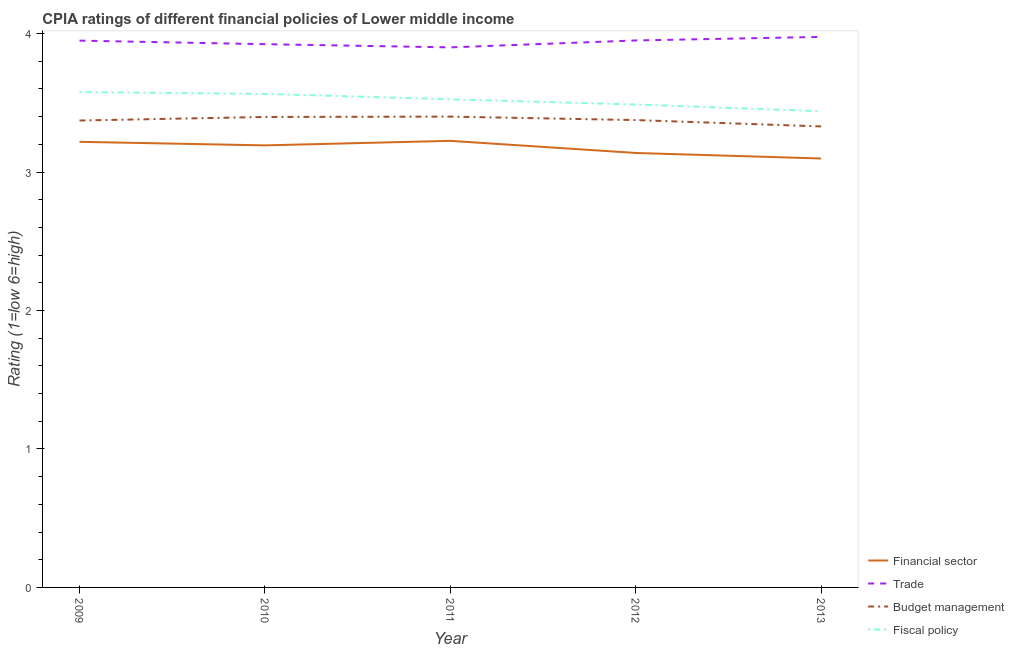How many different coloured lines are there?
Offer a very short reply. 4. What is the cpia rating of fiscal policy in 2013?
Your answer should be compact. 3.44. Across all years, what is the maximum cpia rating of trade?
Provide a short and direct response. 3.98. Across all years, what is the minimum cpia rating of financial sector?
Give a very brief answer. 3.1. In which year was the cpia rating of budget management maximum?
Provide a succinct answer. 2011. What is the total cpia rating of financial sector in the graph?
Make the answer very short. 15.87. What is the difference between the cpia rating of financial sector in 2011 and that in 2013?
Your answer should be compact. 0.13. What is the difference between the cpia rating of trade in 2011 and the cpia rating of fiscal policy in 2012?
Make the answer very short. 0.41. What is the average cpia rating of fiscal policy per year?
Your answer should be compact. 3.52. In the year 2012, what is the difference between the cpia rating of financial sector and cpia rating of budget management?
Provide a succinct answer. -0.24. In how many years, is the cpia rating of budget management greater than 2.8?
Your answer should be compact. 5. What is the ratio of the cpia rating of fiscal policy in 2012 to that in 2013?
Give a very brief answer. 1.01. What is the difference between the highest and the second highest cpia rating of trade?
Offer a very short reply. 0.03. What is the difference between the highest and the lowest cpia rating of financial sector?
Offer a very short reply. 0.13. In how many years, is the cpia rating of financial sector greater than the average cpia rating of financial sector taken over all years?
Offer a very short reply. 3. Is it the case that in every year, the sum of the cpia rating of financial sector and cpia rating of budget management is greater than the sum of cpia rating of fiscal policy and cpia rating of trade?
Provide a succinct answer. No. Is it the case that in every year, the sum of the cpia rating of financial sector and cpia rating of trade is greater than the cpia rating of budget management?
Keep it short and to the point. Yes. Is the cpia rating of trade strictly less than the cpia rating of financial sector over the years?
Give a very brief answer. No. How many lines are there?
Provide a succinct answer. 4. What is the difference between two consecutive major ticks on the Y-axis?
Provide a succinct answer. 1. Does the graph contain grids?
Your response must be concise. No. Where does the legend appear in the graph?
Your response must be concise. Bottom right. What is the title of the graph?
Offer a terse response. CPIA ratings of different financial policies of Lower middle income. What is the Rating (1=low 6=high) in Financial sector in 2009?
Keep it short and to the point. 3.22. What is the Rating (1=low 6=high) in Trade in 2009?
Make the answer very short. 3.95. What is the Rating (1=low 6=high) in Budget management in 2009?
Make the answer very short. 3.37. What is the Rating (1=low 6=high) of Fiscal policy in 2009?
Your response must be concise. 3.58. What is the Rating (1=low 6=high) of Financial sector in 2010?
Your answer should be very brief. 3.19. What is the Rating (1=low 6=high) of Trade in 2010?
Provide a succinct answer. 3.92. What is the Rating (1=low 6=high) in Budget management in 2010?
Provide a short and direct response. 3.4. What is the Rating (1=low 6=high) in Fiscal policy in 2010?
Provide a short and direct response. 3.56. What is the Rating (1=low 6=high) of Financial sector in 2011?
Offer a very short reply. 3.23. What is the Rating (1=low 6=high) of Fiscal policy in 2011?
Ensure brevity in your answer.  3.52. What is the Rating (1=low 6=high) of Financial sector in 2012?
Ensure brevity in your answer.  3.14. What is the Rating (1=low 6=high) of Trade in 2012?
Ensure brevity in your answer.  3.95. What is the Rating (1=low 6=high) of Budget management in 2012?
Offer a very short reply. 3.38. What is the Rating (1=low 6=high) in Fiscal policy in 2012?
Make the answer very short. 3.49. What is the Rating (1=low 6=high) in Financial sector in 2013?
Provide a short and direct response. 3.1. What is the Rating (1=low 6=high) of Trade in 2013?
Give a very brief answer. 3.98. What is the Rating (1=low 6=high) of Budget management in 2013?
Your answer should be compact. 3.33. What is the Rating (1=low 6=high) in Fiscal policy in 2013?
Your response must be concise. 3.44. Across all years, what is the maximum Rating (1=low 6=high) in Financial sector?
Keep it short and to the point. 3.23. Across all years, what is the maximum Rating (1=low 6=high) in Trade?
Ensure brevity in your answer.  3.98. Across all years, what is the maximum Rating (1=low 6=high) of Fiscal policy?
Your response must be concise. 3.58. Across all years, what is the minimum Rating (1=low 6=high) of Financial sector?
Offer a terse response. 3.1. Across all years, what is the minimum Rating (1=low 6=high) in Trade?
Offer a terse response. 3.9. Across all years, what is the minimum Rating (1=low 6=high) of Budget management?
Make the answer very short. 3.33. Across all years, what is the minimum Rating (1=low 6=high) of Fiscal policy?
Offer a terse response. 3.44. What is the total Rating (1=low 6=high) in Financial sector in the graph?
Give a very brief answer. 15.87. What is the total Rating (1=low 6=high) in Trade in the graph?
Your answer should be compact. 19.7. What is the total Rating (1=low 6=high) of Budget management in the graph?
Your answer should be compact. 16.87. What is the total Rating (1=low 6=high) of Fiscal policy in the graph?
Offer a very short reply. 17.59. What is the difference between the Rating (1=low 6=high) in Financial sector in 2009 and that in 2010?
Ensure brevity in your answer.  0.03. What is the difference between the Rating (1=low 6=high) in Trade in 2009 and that in 2010?
Provide a short and direct response. 0.03. What is the difference between the Rating (1=low 6=high) in Budget management in 2009 and that in 2010?
Your answer should be compact. -0.03. What is the difference between the Rating (1=low 6=high) of Fiscal policy in 2009 and that in 2010?
Offer a very short reply. 0.01. What is the difference between the Rating (1=low 6=high) of Financial sector in 2009 and that in 2011?
Make the answer very short. -0.01. What is the difference between the Rating (1=low 6=high) in Trade in 2009 and that in 2011?
Keep it short and to the point. 0.05. What is the difference between the Rating (1=low 6=high) of Budget management in 2009 and that in 2011?
Your answer should be very brief. -0.03. What is the difference between the Rating (1=low 6=high) of Fiscal policy in 2009 and that in 2011?
Your answer should be compact. 0.05. What is the difference between the Rating (1=low 6=high) of Financial sector in 2009 and that in 2012?
Provide a succinct answer. 0.08. What is the difference between the Rating (1=low 6=high) in Trade in 2009 and that in 2012?
Your answer should be compact. -0. What is the difference between the Rating (1=low 6=high) of Budget management in 2009 and that in 2012?
Keep it short and to the point. -0. What is the difference between the Rating (1=low 6=high) in Fiscal policy in 2009 and that in 2012?
Offer a terse response. 0.09. What is the difference between the Rating (1=low 6=high) in Financial sector in 2009 and that in 2013?
Your response must be concise. 0.12. What is the difference between the Rating (1=low 6=high) of Trade in 2009 and that in 2013?
Your answer should be compact. -0.03. What is the difference between the Rating (1=low 6=high) of Budget management in 2009 and that in 2013?
Offer a terse response. 0.04. What is the difference between the Rating (1=low 6=high) in Fiscal policy in 2009 and that in 2013?
Provide a succinct answer. 0.14. What is the difference between the Rating (1=low 6=high) of Financial sector in 2010 and that in 2011?
Give a very brief answer. -0.03. What is the difference between the Rating (1=low 6=high) in Trade in 2010 and that in 2011?
Ensure brevity in your answer.  0.02. What is the difference between the Rating (1=low 6=high) of Budget management in 2010 and that in 2011?
Ensure brevity in your answer.  -0. What is the difference between the Rating (1=low 6=high) of Fiscal policy in 2010 and that in 2011?
Your answer should be compact. 0.04. What is the difference between the Rating (1=low 6=high) of Financial sector in 2010 and that in 2012?
Ensure brevity in your answer.  0.05. What is the difference between the Rating (1=low 6=high) in Trade in 2010 and that in 2012?
Provide a succinct answer. -0.03. What is the difference between the Rating (1=low 6=high) in Budget management in 2010 and that in 2012?
Your answer should be very brief. 0.02. What is the difference between the Rating (1=low 6=high) of Fiscal policy in 2010 and that in 2012?
Provide a short and direct response. 0.08. What is the difference between the Rating (1=low 6=high) in Financial sector in 2010 and that in 2013?
Ensure brevity in your answer.  0.09. What is the difference between the Rating (1=low 6=high) of Trade in 2010 and that in 2013?
Keep it short and to the point. -0.05. What is the difference between the Rating (1=low 6=high) in Budget management in 2010 and that in 2013?
Provide a short and direct response. 0.07. What is the difference between the Rating (1=low 6=high) of Fiscal policy in 2010 and that in 2013?
Give a very brief answer. 0.13. What is the difference between the Rating (1=low 6=high) in Financial sector in 2011 and that in 2012?
Provide a short and direct response. 0.09. What is the difference between the Rating (1=low 6=high) in Trade in 2011 and that in 2012?
Give a very brief answer. -0.05. What is the difference between the Rating (1=low 6=high) in Budget management in 2011 and that in 2012?
Give a very brief answer. 0.03. What is the difference between the Rating (1=low 6=high) of Fiscal policy in 2011 and that in 2012?
Keep it short and to the point. 0.04. What is the difference between the Rating (1=low 6=high) in Financial sector in 2011 and that in 2013?
Your answer should be compact. 0.13. What is the difference between the Rating (1=low 6=high) of Trade in 2011 and that in 2013?
Offer a terse response. -0.08. What is the difference between the Rating (1=low 6=high) in Budget management in 2011 and that in 2013?
Provide a succinct answer. 0.07. What is the difference between the Rating (1=low 6=high) in Fiscal policy in 2011 and that in 2013?
Your response must be concise. 0.09. What is the difference between the Rating (1=low 6=high) of Financial sector in 2012 and that in 2013?
Offer a terse response. 0.04. What is the difference between the Rating (1=low 6=high) of Trade in 2012 and that in 2013?
Your answer should be very brief. -0.03. What is the difference between the Rating (1=low 6=high) of Budget management in 2012 and that in 2013?
Ensure brevity in your answer.  0.05. What is the difference between the Rating (1=low 6=high) in Fiscal policy in 2012 and that in 2013?
Provide a succinct answer. 0.05. What is the difference between the Rating (1=low 6=high) in Financial sector in 2009 and the Rating (1=low 6=high) in Trade in 2010?
Give a very brief answer. -0.71. What is the difference between the Rating (1=low 6=high) of Financial sector in 2009 and the Rating (1=low 6=high) of Budget management in 2010?
Ensure brevity in your answer.  -0.18. What is the difference between the Rating (1=low 6=high) of Financial sector in 2009 and the Rating (1=low 6=high) of Fiscal policy in 2010?
Offer a very short reply. -0.35. What is the difference between the Rating (1=low 6=high) in Trade in 2009 and the Rating (1=low 6=high) in Budget management in 2010?
Offer a very short reply. 0.55. What is the difference between the Rating (1=low 6=high) in Trade in 2009 and the Rating (1=low 6=high) in Fiscal policy in 2010?
Your response must be concise. 0.38. What is the difference between the Rating (1=low 6=high) of Budget management in 2009 and the Rating (1=low 6=high) of Fiscal policy in 2010?
Offer a very short reply. -0.19. What is the difference between the Rating (1=low 6=high) of Financial sector in 2009 and the Rating (1=low 6=high) of Trade in 2011?
Provide a succinct answer. -0.68. What is the difference between the Rating (1=low 6=high) in Financial sector in 2009 and the Rating (1=low 6=high) in Budget management in 2011?
Your answer should be very brief. -0.18. What is the difference between the Rating (1=low 6=high) of Financial sector in 2009 and the Rating (1=low 6=high) of Fiscal policy in 2011?
Provide a short and direct response. -0.31. What is the difference between the Rating (1=low 6=high) in Trade in 2009 and the Rating (1=low 6=high) in Budget management in 2011?
Your response must be concise. 0.55. What is the difference between the Rating (1=low 6=high) of Trade in 2009 and the Rating (1=low 6=high) of Fiscal policy in 2011?
Make the answer very short. 0.42. What is the difference between the Rating (1=low 6=high) of Budget management in 2009 and the Rating (1=low 6=high) of Fiscal policy in 2011?
Give a very brief answer. -0.15. What is the difference between the Rating (1=low 6=high) of Financial sector in 2009 and the Rating (1=low 6=high) of Trade in 2012?
Ensure brevity in your answer.  -0.73. What is the difference between the Rating (1=low 6=high) of Financial sector in 2009 and the Rating (1=low 6=high) of Budget management in 2012?
Your answer should be very brief. -0.16. What is the difference between the Rating (1=low 6=high) in Financial sector in 2009 and the Rating (1=low 6=high) in Fiscal policy in 2012?
Your answer should be compact. -0.27. What is the difference between the Rating (1=low 6=high) of Trade in 2009 and the Rating (1=low 6=high) of Budget management in 2012?
Ensure brevity in your answer.  0.57. What is the difference between the Rating (1=low 6=high) in Trade in 2009 and the Rating (1=low 6=high) in Fiscal policy in 2012?
Keep it short and to the point. 0.46. What is the difference between the Rating (1=low 6=high) of Budget management in 2009 and the Rating (1=low 6=high) of Fiscal policy in 2012?
Keep it short and to the point. -0.12. What is the difference between the Rating (1=low 6=high) of Financial sector in 2009 and the Rating (1=low 6=high) of Trade in 2013?
Give a very brief answer. -0.76. What is the difference between the Rating (1=low 6=high) of Financial sector in 2009 and the Rating (1=low 6=high) of Budget management in 2013?
Offer a terse response. -0.11. What is the difference between the Rating (1=low 6=high) of Financial sector in 2009 and the Rating (1=low 6=high) of Fiscal policy in 2013?
Offer a terse response. -0.22. What is the difference between the Rating (1=low 6=high) of Trade in 2009 and the Rating (1=low 6=high) of Budget management in 2013?
Offer a very short reply. 0.62. What is the difference between the Rating (1=low 6=high) in Trade in 2009 and the Rating (1=low 6=high) in Fiscal policy in 2013?
Make the answer very short. 0.51. What is the difference between the Rating (1=low 6=high) in Budget management in 2009 and the Rating (1=low 6=high) in Fiscal policy in 2013?
Your answer should be compact. -0.07. What is the difference between the Rating (1=low 6=high) in Financial sector in 2010 and the Rating (1=low 6=high) in Trade in 2011?
Provide a succinct answer. -0.71. What is the difference between the Rating (1=low 6=high) of Financial sector in 2010 and the Rating (1=low 6=high) of Budget management in 2011?
Make the answer very short. -0.21. What is the difference between the Rating (1=low 6=high) of Financial sector in 2010 and the Rating (1=low 6=high) of Fiscal policy in 2011?
Make the answer very short. -0.33. What is the difference between the Rating (1=low 6=high) of Trade in 2010 and the Rating (1=low 6=high) of Budget management in 2011?
Offer a very short reply. 0.52. What is the difference between the Rating (1=low 6=high) in Trade in 2010 and the Rating (1=low 6=high) in Fiscal policy in 2011?
Give a very brief answer. 0.4. What is the difference between the Rating (1=low 6=high) of Budget management in 2010 and the Rating (1=low 6=high) of Fiscal policy in 2011?
Your response must be concise. -0.13. What is the difference between the Rating (1=low 6=high) of Financial sector in 2010 and the Rating (1=low 6=high) of Trade in 2012?
Give a very brief answer. -0.76. What is the difference between the Rating (1=low 6=high) in Financial sector in 2010 and the Rating (1=low 6=high) in Budget management in 2012?
Your response must be concise. -0.18. What is the difference between the Rating (1=low 6=high) in Financial sector in 2010 and the Rating (1=low 6=high) in Fiscal policy in 2012?
Give a very brief answer. -0.3. What is the difference between the Rating (1=low 6=high) of Trade in 2010 and the Rating (1=low 6=high) of Budget management in 2012?
Provide a short and direct response. 0.55. What is the difference between the Rating (1=low 6=high) in Trade in 2010 and the Rating (1=low 6=high) in Fiscal policy in 2012?
Provide a short and direct response. 0.44. What is the difference between the Rating (1=low 6=high) in Budget management in 2010 and the Rating (1=low 6=high) in Fiscal policy in 2012?
Offer a terse response. -0.09. What is the difference between the Rating (1=low 6=high) in Financial sector in 2010 and the Rating (1=low 6=high) in Trade in 2013?
Provide a short and direct response. -0.78. What is the difference between the Rating (1=low 6=high) of Financial sector in 2010 and the Rating (1=low 6=high) of Budget management in 2013?
Offer a terse response. -0.14. What is the difference between the Rating (1=low 6=high) of Financial sector in 2010 and the Rating (1=low 6=high) of Fiscal policy in 2013?
Your answer should be compact. -0.25. What is the difference between the Rating (1=low 6=high) in Trade in 2010 and the Rating (1=low 6=high) in Budget management in 2013?
Provide a short and direct response. 0.59. What is the difference between the Rating (1=low 6=high) of Trade in 2010 and the Rating (1=low 6=high) of Fiscal policy in 2013?
Give a very brief answer. 0.48. What is the difference between the Rating (1=low 6=high) in Budget management in 2010 and the Rating (1=low 6=high) in Fiscal policy in 2013?
Provide a short and direct response. -0.04. What is the difference between the Rating (1=low 6=high) of Financial sector in 2011 and the Rating (1=low 6=high) of Trade in 2012?
Keep it short and to the point. -0.72. What is the difference between the Rating (1=low 6=high) in Financial sector in 2011 and the Rating (1=low 6=high) in Fiscal policy in 2012?
Make the answer very short. -0.26. What is the difference between the Rating (1=low 6=high) of Trade in 2011 and the Rating (1=low 6=high) of Budget management in 2012?
Provide a succinct answer. 0.53. What is the difference between the Rating (1=low 6=high) in Trade in 2011 and the Rating (1=low 6=high) in Fiscal policy in 2012?
Provide a short and direct response. 0.41. What is the difference between the Rating (1=low 6=high) in Budget management in 2011 and the Rating (1=low 6=high) in Fiscal policy in 2012?
Make the answer very short. -0.09. What is the difference between the Rating (1=low 6=high) in Financial sector in 2011 and the Rating (1=low 6=high) in Trade in 2013?
Your answer should be compact. -0.75. What is the difference between the Rating (1=low 6=high) in Financial sector in 2011 and the Rating (1=low 6=high) in Budget management in 2013?
Offer a very short reply. -0.1. What is the difference between the Rating (1=low 6=high) in Financial sector in 2011 and the Rating (1=low 6=high) in Fiscal policy in 2013?
Your answer should be very brief. -0.21. What is the difference between the Rating (1=low 6=high) in Trade in 2011 and the Rating (1=low 6=high) in Budget management in 2013?
Provide a succinct answer. 0.57. What is the difference between the Rating (1=low 6=high) of Trade in 2011 and the Rating (1=low 6=high) of Fiscal policy in 2013?
Offer a terse response. 0.46. What is the difference between the Rating (1=low 6=high) of Budget management in 2011 and the Rating (1=low 6=high) of Fiscal policy in 2013?
Ensure brevity in your answer.  -0.04. What is the difference between the Rating (1=low 6=high) in Financial sector in 2012 and the Rating (1=low 6=high) in Trade in 2013?
Your answer should be compact. -0.84. What is the difference between the Rating (1=low 6=high) of Financial sector in 2012 and the Rating (1=low 6=high) of Budget management in 2013?
Give a very brief answer. -0.19. What is the difference between the Rating (1=low 6=high) in Financial sector in 2012 and the Rating (1=low 6=high) in Fiscal policy in 2013?
Provide a succinct answer. -0.3. What is the difference between the Rating (1=low 6=high) in Trade in 2012 and the Rating (1=low 6=high) in Budget management in 2013?
Provide a short and direct response. 0.62. What is the difference between the Rating (1=low 6=high) in Trade in 2012 and the Rating (1=low 6=high) in Fiscal policy in 2013?
Keep it short and to the point. 0.51. What is the difference between the Rating (1=low 6=high) in Budget management in 2012 and the Rating (1=low 6=high) in Fiscal policy in 2013?
Your response must be concise. -0.06. What is the average Rating (1=low 6=high) in Financial sector per year?
Offer a very short reply. 3.17. What is the average Rating (1=low 6=high) in Trade per year?
Offer a terse response. 3.94. What is the average Rating (1=low 6=high) in Budget management per year?
Keep it short and to the point. 3.37. What is the average Rating (1=low 6=high) of Fiscal policy per year?
Ensure brevity in your answer.  3.52. In the year 2009, what is the difference between the Rating (1=low 6=high) of Financial sector and Rating (1=low 6=high) of Trade?
Ensure brevity in your answer.  -0.73. In the year 2009, what is the difference between the Rating (1=low 6=high) in Financial sector and Rating (1=low 6=high) in Budget management?
Your answer should be very brief. -0.15. In the year 2009, what is the difference between the Rating (1=low 6=high) of Financial sector and Rating (1=low 6=high) of Fiscal policy?
Your response must be concise. -0.36. In the year 2009, what is the difference between the Rating (1=low 6=high) in Trade and Rating (1=low 6=high) in Budget management?
Offer a very short reply. 0.58. In the year 2009, what is the difference between the Rating (1=low 6=high) of Trade and Rating (1=low 6=high) of Fiscal policy?
Your response must be concise. 0.37. In the year 2009, what is the difference between the Rating (1=low 6=high) in Budget management and Rating (1=low 6=high) in Fiscal policy?
Your answer should be compact. -0.21. In the year 2010, what is the difference between the Rating (1=low 6=high) of Financial sector and Rating (1=low 6=high) of Trade?
Ensure brevity in your answer.  -0.73. In the year 2010, what is the difference between the Rating (1=low 6=high) of Financial sector and Rating (1=low 6=high) of Budget management?
Provide a succinct answer. -0.21. In the year 2010, what is the difference between the Rating (1=low 6=high) of Financial sector and Rating (1=low 6=high) of Fiscal policy?
Provide a short and direct response. -0.37. In the year 2010, what is the difference between the Rating (1=low 6=high) of Trade and Rating (1=low 6=high) of Budget management?
Provide a short and direct response. 0.53. In the year 2010, what is the difference between the Rating (1=low 6=high) in Trade and Rating (1=low 6=high) in Fiscal policy?
Your answer should be compact. 0.36. In the year 2011, what is the difference between the Rating (1=low 6=high) in Financial sector and Rating (1=low 6=high) in Trade?
Keep it short and to the point. -0.68. In the year 2011, what is the difference between the Rating (1=low 6=high) in Financial sector and Rating (1=low 6=high) in Budget management?
Give a very brief answer. -0.17. In the year 2011, what is the difference between the Rating (1=low 6=high) of Trade and Rating (1=low 6=high) of Budget management?
Offer a terse response. 0.5. In the year 2011, what is the difference between the Rating (1=low 6=high) of Budget management and Rating (1=low 6=high) of Fiscal policy?
Offer a very short reply. -0.12. In the year 2012, what is the difference between the Rating (1=low 6=high) of Financial sector and Rating (1=low 6=high) of Trade?
Your answer should be compact. -0.81. In the year 2012, what is the difference between the Rating (1=low 6=high) of Financial sector and Rating (1=low 6=high) of Budget management?
Offer a terse response. -0.24. In the year 2012, what is the difference between the Rating (1=low 6=high) in Financial sector and Rating (1=low 6=high) in Fiscal policy?
Your answer should be very brief. -0.35. In the year 2012, what is the difference between the Rating (1=low 6=high) in Trade and Rating (1=low 6=high) in Budget management?
Give a very brief answer. 0.57. In the year 2012, what is the difference between the Rating (1=low 6=high) of Trade and Rating (1=low 6=high) of Fiscal policy?
Provide a succinct answer. 0.46. In the year 2012, what is the difference between the Rating (1=low 6=high) of Budget management and Rating (1=low 6=high) of Fiscal policy?
Make the answer very short. -0.11. In the year 2013, what is the difference between the Rating (1=low 6=high) in Financial sector and Rating (1=low 6=high) in Trade?
Offer a very short reply. -0.88. In the year 2013, what is the difference between the Rating (1=low 6=high) of Financial sector and Rating (1=low 6=high) of Budget management?
Make the answer very short. -0.23. In the year 2013, what is the difference between the Rating (1=low 6=high) in Financial sector and Rating (1=low 6=high) in Fiscal policy?
Offer a very short reply. -0.34. In the year 2013, what is the difference between the Rating (1=low 6=high) in Trade and Rating (1=low 6=high) in Budget management?
Offer a terse response. 0.65. In the year 2013, what is the difference between the Rating (1=low 6=high) in Trade and Rating (1=low 6=high) in Fiscal policy?
Ensure brevity in your answer.  0.54. In the year 2013, what is the difference between the Rating (1=low 6=high) of Budget management and Rating (1=low 6=high) of Fiscal policy?
Your response must be concise. -0.11. What is the ratio of the Rating (1=low 6=high) of Financial sector in 2009 to that in 2010?
Keep it short and to the point. 1.01. What is the ratio of the Rating (1=low 6=high) in Budget management in 2009 to that in 2010?
Offer a terse response. 0.99. What is the ratio of the Rating (1=low 6=high) of Fiscal policy in 2009 to that in 2010?
Offer a very short reply. 1. What is the ratio of the Rating (1=low 6=high) in Financial sector in 2009 to that in 2011?
Provide a short and direct response. 1. What is the ratio of the Rating (1=low 6=high) in Trade in 2009 to that in 2011?
Provide a succinct answer. 1.01. What is the ratio of the Rating (1=low 6=high) of Fiscal policy in 2009 to that in 2011?
Give a very brief answer. 1.01. What is the ratio of the Rating (1=low 6=high) in Financial sector in 2009 to that in 2012?
Provide a short and direct response. 1.03. What is the ratio of the Rating (1=low 6=high) in Budget management in 2009 to that in 2012?
Make the answer very short. 1. What is the ratio of the Rating (1=low 6=high) of Fiscal policy in 2009 to that in 2012?
Your response must be concise. 1.03. What is the ratio of the Rating (1=low 6=high) in Financial sector in 2009 to that in 2013?
Provide a succinct answer. 1.04. What is the ratio of the Rating (1=low 6=high) of Trade in 2009 to that in 2013?
Offer a very short reply. 0.99. What is the ratio of the Rating (1=low 6=high) in Budget management in 2009 to that in 2013?
Your answer should be very brief. 1.01. What is the ratio of the Rating (1=low 6=high) of Fiscal policy in 2009 to that in 2013?
Ensure brevity in your answer.  1.04. What is the ratio of the Rating (1=low 6=high) in Financial sector in 2010 to that in 2011?
Make the answer very short. 0.99. What is the ratio of the Rating (1=low 6=high) in Trade in 2010 to that in 2011?
Offer a terse response. 1.01. What is the ratio of the Rating (1=low 6=high) in Budget management in 2010 to that in 2011?
Keep it short and to the point. 1. What is the ratio of the Rating (1=low 6=high) of Fiscal policy in 2010 to that in 2011?
Offer a terse response. 1.01. What is the ratio of the Rating (1=low 6=high) in Financial sector in 2010 to that in 2012?
Provide a short and direct response. 1.02. What is the ratio of the Rating (1=low 6=high) of Trade in 2010 to that in 2012?
Your response must be concise. 0.99. What is the ratio of the Rating (1=low 6=high) of Budget management in 2010 to that in 2012?
Provide a short and direct response. 1.01. What is the ratio of the Rating (1=low 6=high) of Fiscal policy in 2010 to that in 2012?
Provide a short and direct response. 1.02. What is the ratio of the Rating (1=low 6=high) of Financial sector in 2010 to that in 2013?
Offer a very short reply. 1.03. What is the ratio of the Rating (1=low 6=high) of Budget management in 2010 to that in 2013?
Offer a terse response. 1.02. What is the ratio of the Rating (1=low 6=high) of Fiscal policy in 2010 to that in 2013?
Your response must be concise. 1.04. What is the ratio of the Rating (1=low 6=high) of Financial sector in 2011 to that in 2012?
Give a very brief answer. 1.03. What is the ratio of the Rating (1=low 6=high) in Trade in 2011 to that in 2012?
Offer a very short reply. 0.99. What is the ratio of the Rating (1=low 6=high) of Budget management in 2011 to that in 2012?
Provide a succinct answer. 1.01. What is the ratio of the Rating (1=low 6=high) in Fiscal policy in 2011 to that in 2012?
Offer a very short reply. 1.01. What is the ratio of the Rating (1=low 6=high) of Financial sector in 2011 to that in 2013?
Offer a terse response. 1.04. What is the ratio of the Rating (1=low 6=high) in Budget management in 2011 to that in 2013?
Give a very brief answer. 1.02. What is the ratio of the Rating (1=low 6=high) of Financial sector in 2012 to that in 2013?
Your response must be concise. 1.01. What is the ratio of the Rating (1=low 6=high) of Trade in 2012 to that in 2013?
Provide a short and direct response. 0.99. What is the ratio of the Rating (1=low 6=high) of Budget management in 2012 to that in 2013?
Offer a very short reply. 1.01. What is the ratio of the Rating (1=low 6=high) in Fiscal policy in 2012 to that in 2013?
Give a very brief answer. 1.01. What is the difference between the highest and the second highest Rating (1=low 6=high) in Financial sector?
Your answer should be very brief. 0.01. What is the difference between the highest and the second highest Rating (1=low 6=high) in Trade?
Offer a terse response. 0.03. What is the difference between the highest and the second highest Rating (1=low 6=high) in Budget management?
Provide a succinct answer. 0. What is the difference between the highest and the second highest Rating (1=low 6=high) in Fiscal policy?
Your response must be concise. 0.01. What is the difference between the highest and the lowest Rating (1=low 6=high) in Financial sector?
Your answer should be very brief. 0.13. What is the difference between the highest and the lowest Rating (1=low 6=high) of Trade?
Give a very brief answer. 0.08. What is the difference between the highest and the lowest Rating (1=low 6=high) of Budget management?
Your answer should be very brief. 0.07. What is the difference between the highest and the lowest Rating (1=low 6=high) in Fiscal policy?
Give a very brief answer. 0.14. 